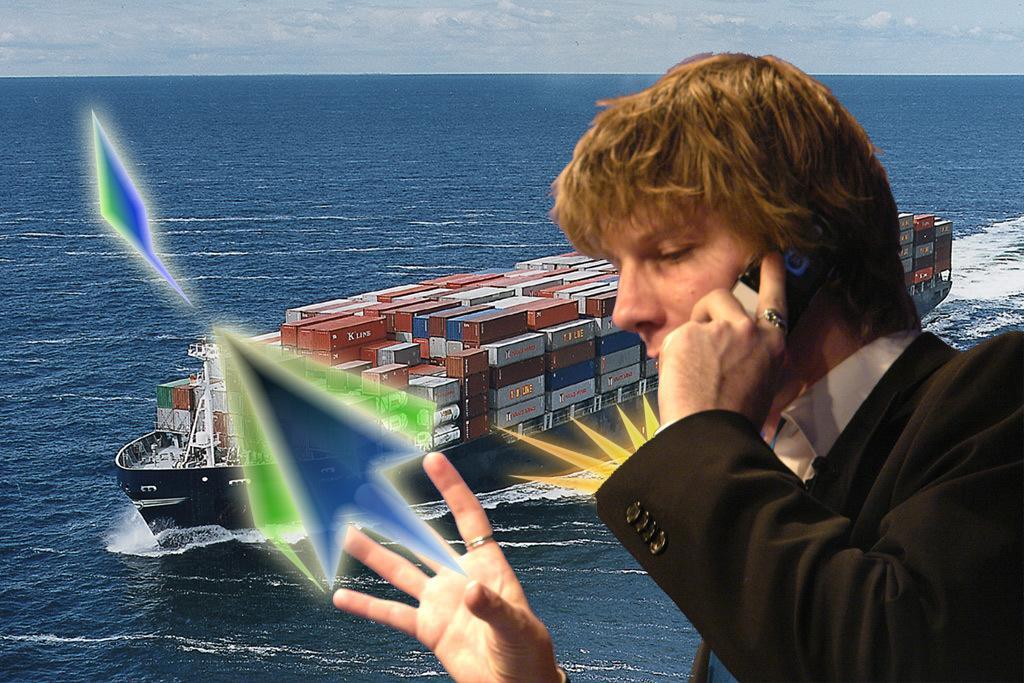Please provide a concise description of this image. This image is an edited image. In this image on the right there is a man, he wears a suit, shirt, he is holding a mobile. In the middle there are waves, water, boat, sky and clouds. In the middle there is a boat on that there are many containers. 